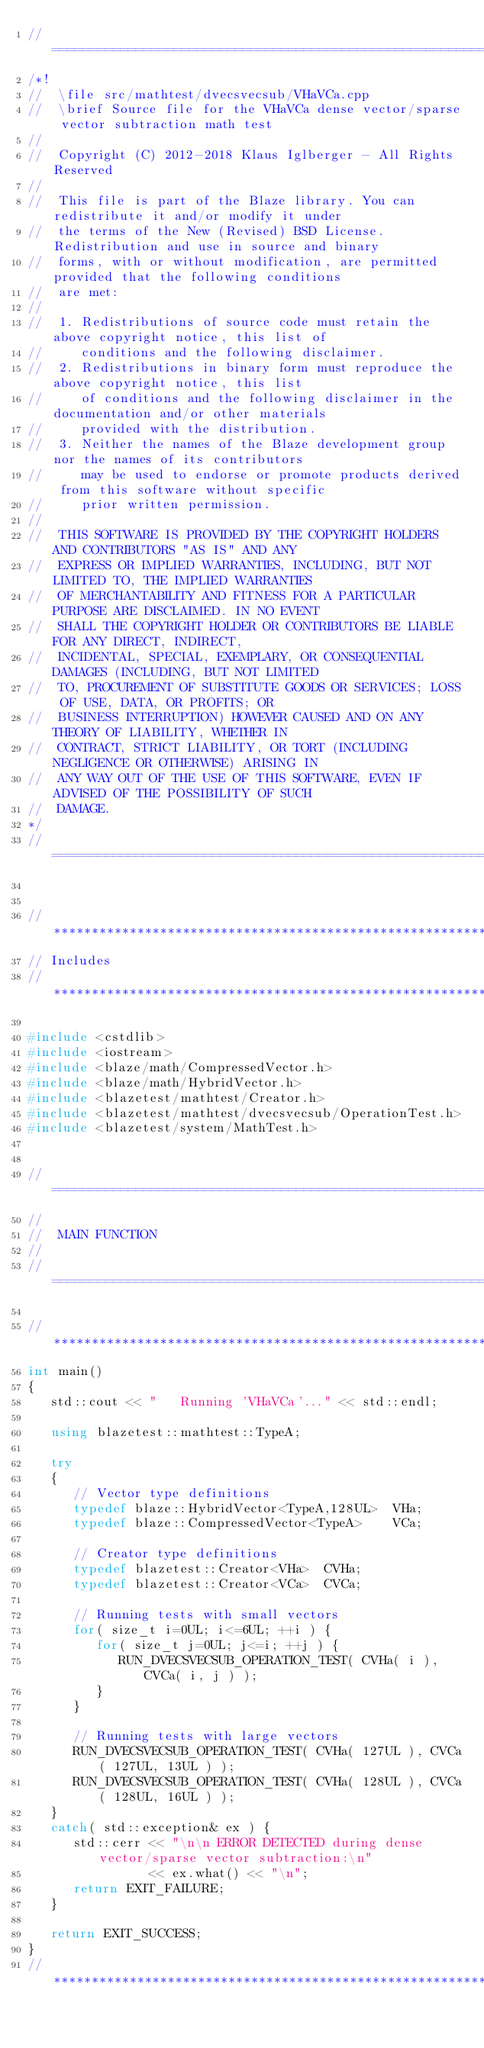Convert code to text. <code><loc_0><loc_0><loc_500><loc_500><_C++_>//=================================================================================================
/*!
//  \file src/mathtest/dvecsvecsub/VHaVCa.cpp
//  \brief Source file for the VHaVCa dense vector/sparse vector subtraction math test
//
//  Copyright (C) 2012-2018 Klaus Iglberger - All Rights Reserved
//
//  This file is part of the Blaze library. You can redistribute it and/or modify it under
//  the terms of the New (Revised) BSD License. Redistribution and use in source and binary
//  forms, with or without modification, are permitted provided that the following conditions
//  are met:
//
//  1. Redistributions of source code must retain the above copyright notice, this list of
//     conditions and the following disclaimer.
//  2. Redistributions in binary form must reproduce the above copyright notice, this list
//     of conditions and the following disclaimer in the documentation and/or other materials
//     provided with the distribution.
//  3. Neither the names of the Blaze development group nor the names of its contributors
//     may be used to endorse or promote products derived from this software without specific
//     prior written permission.
//
//  THIS SOFTWARE IS PROVIDED BY THE COPYRIGHT HOLDERS AND CONTRIBUTORS "AS IS" AND ANY
//  EXPRESS OR IMPLIED WARRANTIES, INCLUDING, BUT NOT LIMITED TO, THE IMPLIED WARRANTIES
//  OF MERCHANTABILITY AND FITNESS FOR A PARTICULAR PURPOSE ARE DISCLAIMED. IN NO EVENT
//  SHALL THE COPYRIGHT HOLDER OR CONTRIBUTORS BE LIABLE FOR ANY DIRECT, INDIRECT,
//  INCIDENTAL, SPECIAL, EXEMPLARY, OR CONSEQUENTIAL DAMAGES (INCLUDING, BUT NOT LIMITED
//  TO, PROCUREMENT OF SUBSTITUTE GOODS OR SERVICES; LOSS OF USE, DATA, OR PROFITS; OR
//  BUSINESS INTERRUPTION) HOWEVER CAUSED AND ON ANY THEORY OF LIABILITY, WHETHER IN
//  CONTRACT, STRICT LIABILITY, OR TORT (INCLUDING NEGLIGENCE OR OTHERWISE) ARISING IN
//  ANY WAY OUT OF THE USE OF THIS SOFTWARE, EVEN IF ADVISED OF THE POSSIBILITY OF SUCH
//  DAMAGE.
*/
//=================================================================================================


//*************************************************************************************************
// Includes
//*************************************************************************************************

#include <cstdlib>
#include <iostream>
#include <blaze/math/CompressedVector.h>
#include <blaze/math/HybridVector.h>
#include <blazetest/mathtest/Creator.h>
#include <blazetest/mathtest/dvecsvecsub/OperationTest.h>
#include <blazetest/system/MathTest.h>


//=================================================================================================
//
//  MAIN FUNCTION
//
//=================================================================================================

//*************************************************************************************************
int main()
{
   std::cout << "   Running 'VHaVCa'..." << std::endl;

   using blazetest::mathtest::TypeA;

   try
   {
      // Vector type definitions
      typedef blaze::HybridVector<TypeA,128UL>  VHa;
      typedef blaze::CompressedVector<TypeA>    VCa;

      // Creator type definitions
      typedef blazetest::Creator<VHa>  CVHa;
      typedef blazetest::Creator<VCa>  CVCa;

      // Running tests with small vectors
      for( size_t i=0UL; i<=6UL; ++i ) {
         for( size_t j=0UL; j<=i; ++j ) {
            RUN_DVECSVECSUB_OPERATION_TEST( CVHa( i ), CVCa( i, j ) );
         }
      }

      // Running tests with large vectors
      RUN_DVECSVECSUB_OPERATION_TEST( CVHa( 127UL ), CVCa( 127UL, 13UL ) );
      RUN_DVECSVECSUB_OPERATION_TEST( CVHa( 128UL ), CVCa( 128UL, 16UL ) );
   }
   catch( std::exception& ex ) {
      std::cerr << "\n\n ERROR DETECTED during dense vector/sparse vector subtraction:\n"
                << ex.what() << "\n";
      return EXIT_FAILURE;
   }

   return EXIT_SUCCESS;
}
//*************************************************************************************************
</code> 